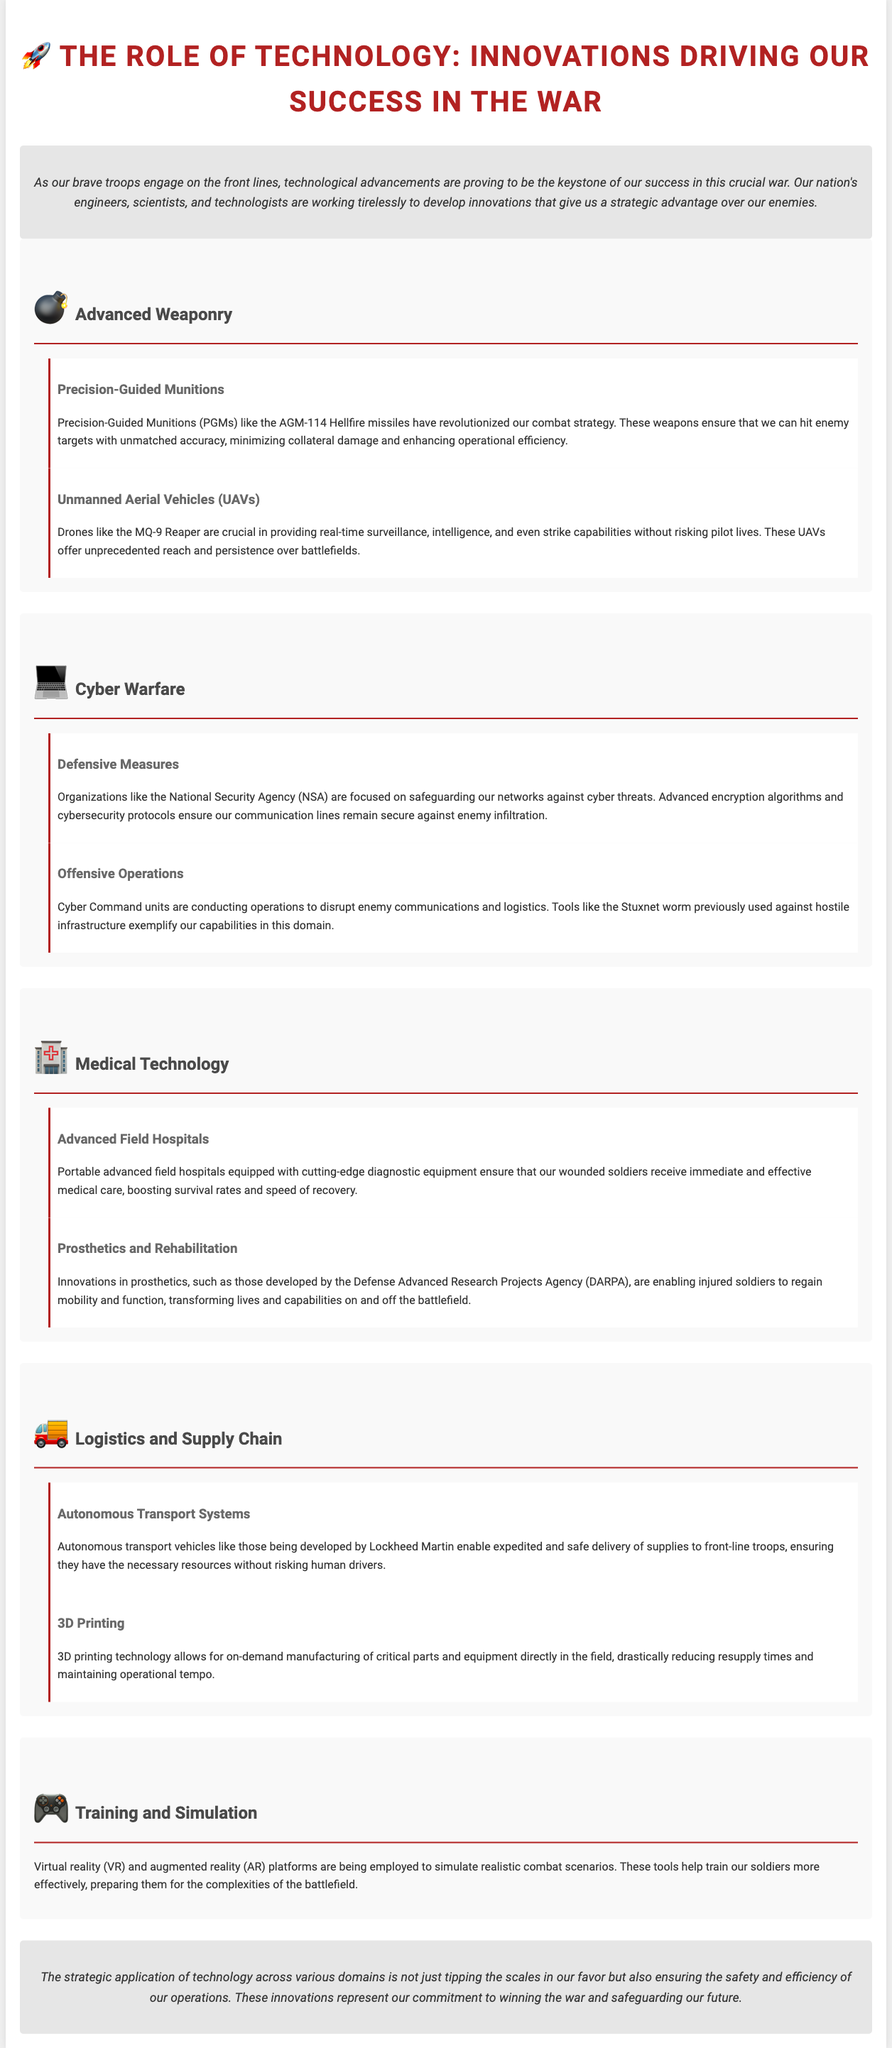What are Precision-Guided Munitions? The document describes Precision-Guided Munitions (PGMs) as weapons that ensure that we can hit enemy targets with unmatched accuracy.
Answer: Weapons that ensure hitting targets with unmatched accuracy What is the purpose of unmanned aerial vehicles? The document explains that unmanned aerial vehicles (UAVs) provide real-time surveillance, intelligence, and strike capabilities without risking pilot lives.
Answer: Providing real-time surveillance, intelligence, and strike capabilities Which organization focuses on safeguarding networks against cyber threats? The document mentions that the NSA is focused on safeguarding our networks against cyber threats.
Answer: NSA What technology allows for on-demand manufacturing of critical parts? According to the document, 3D printing technology allows for on-demand manufacturing of critical parts directly in the field.
Answer: 3D printing technology What role do virtual reality and augmented reality play in training? The document states that virtual reality (VR) and augmented reality (AR) platforms are employed to simulate realistic combat scenarios for training soldiers.
Answer: Simulating realistic combat scenarios What is a key benefit of advanced field hospitals? The document indicates that advanced field hospitals ensure that our wounded soldiers receive immediate and effective medical care.
Answer: Immediate and effective medical care What type of technology is exemplified by the Stuxnet worm? The document illustrates that the Stuxnet worm is an example of tools used for offensive operations in cyber warfare.
Answer: Offensive operations in cyber warfare Which company is developing autonomous transport vehicles? The document notes that Lockheed Martin is developing autonomous transport vehicles.
Answer: Lockheed Martin 